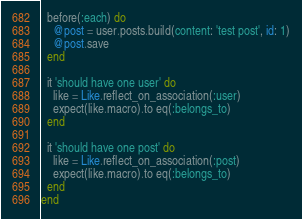<code> <loc_0><loc_0><loc_500><loc_500><_Ruby_>
  before(:each) do
    @post = user.posts.build(content: 'test post', id: 1)
    @post.save
  end

  it 'should have one user' do
    like = Like.reflect_on_association(:user)
    expect(like.macro).to eq(:belongs_to)
  end

  it 'should have one post' do
    like = Like.reflect_on_association(:post)
    expect(like.macro).to eq(:belongs_to)
  end
end
</code> 